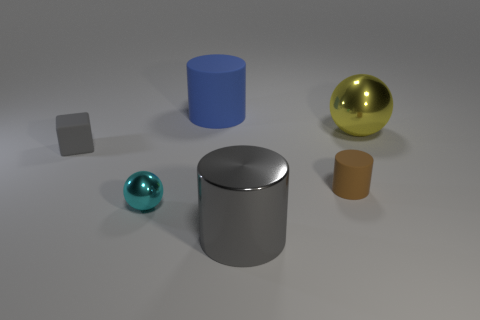Add 3 blue shiny balls. How many objects exist? 9 Subtract all spheres. How many objects are left? 4 Add 4 rubber cylinders. How many rubber cylinders are left? 6 Add 5 small gray metallic cubes. How many small gray metallic cubes exist? 5 Subtract 0 purple spheres. How many objects are left? 6 Subtract all cyan shiny spheres. Subtract all tiny cyan balls. How many objects are left? 4 